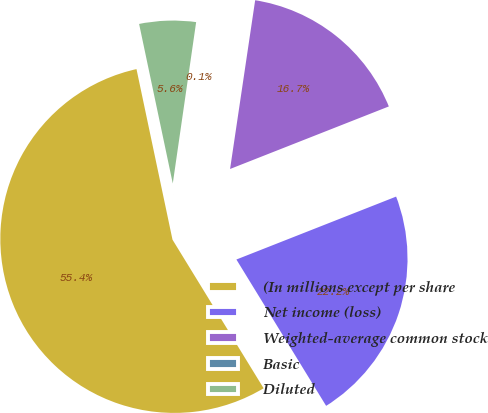<chart> <loc_0><loc_0><loc_500><loc_500><pie_chart><fcel>(In millions except per share<fcel>Net income (loss)<fcel>Weighted-average common stock<fcel>Basic<fcel>Diluted<nl><fcel>55.45%<fcel>22.22%<fcel>16.68%<fcel>0.06%<fcel>5.6%<nl></chart> 